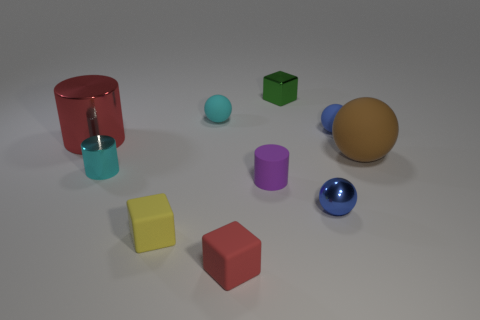There is a small rubber thing that is on the left side of the tiny cyan matte thing; is it the same shape as the cyan thing that is behind the blue rubber sphere?
Your answer should be very brief. No. Are there any tiny blue spheres that have the same material as the purple object?
Your answer should be very brief. Yes. There is a large thing to the left of the tiny ball on the left side of the red matte cube that is to the right of the tiny cyan metallic thing; what color is it?
Your answer should be very brief. Red. Do the ball that is left of the small metallic block and the blue thing that is behind the brown matte thing have the same material?
Offer a very short reply. Yes. What shape is the blue object behind the blue shiny sphere?
Your response must be concise. Sphere. What number of objects are large things or tiny blue objects that are behind the brown matte object?
Make the answer very short. 3. Do the big brown thing and the big red cylinder have the same material?
Your response must be concise. No. Are there the same number of small things that are in front of the small blue shiny sphere and tiny matte cubes that are to the right of the big red cylinder?
Your response must be concise. Yes. How many balls are in front of the small purple cylinder?
Offer a very short reply. 1. What number of objects are brown objects or small cubes?
Your answer should be compact. 4. 